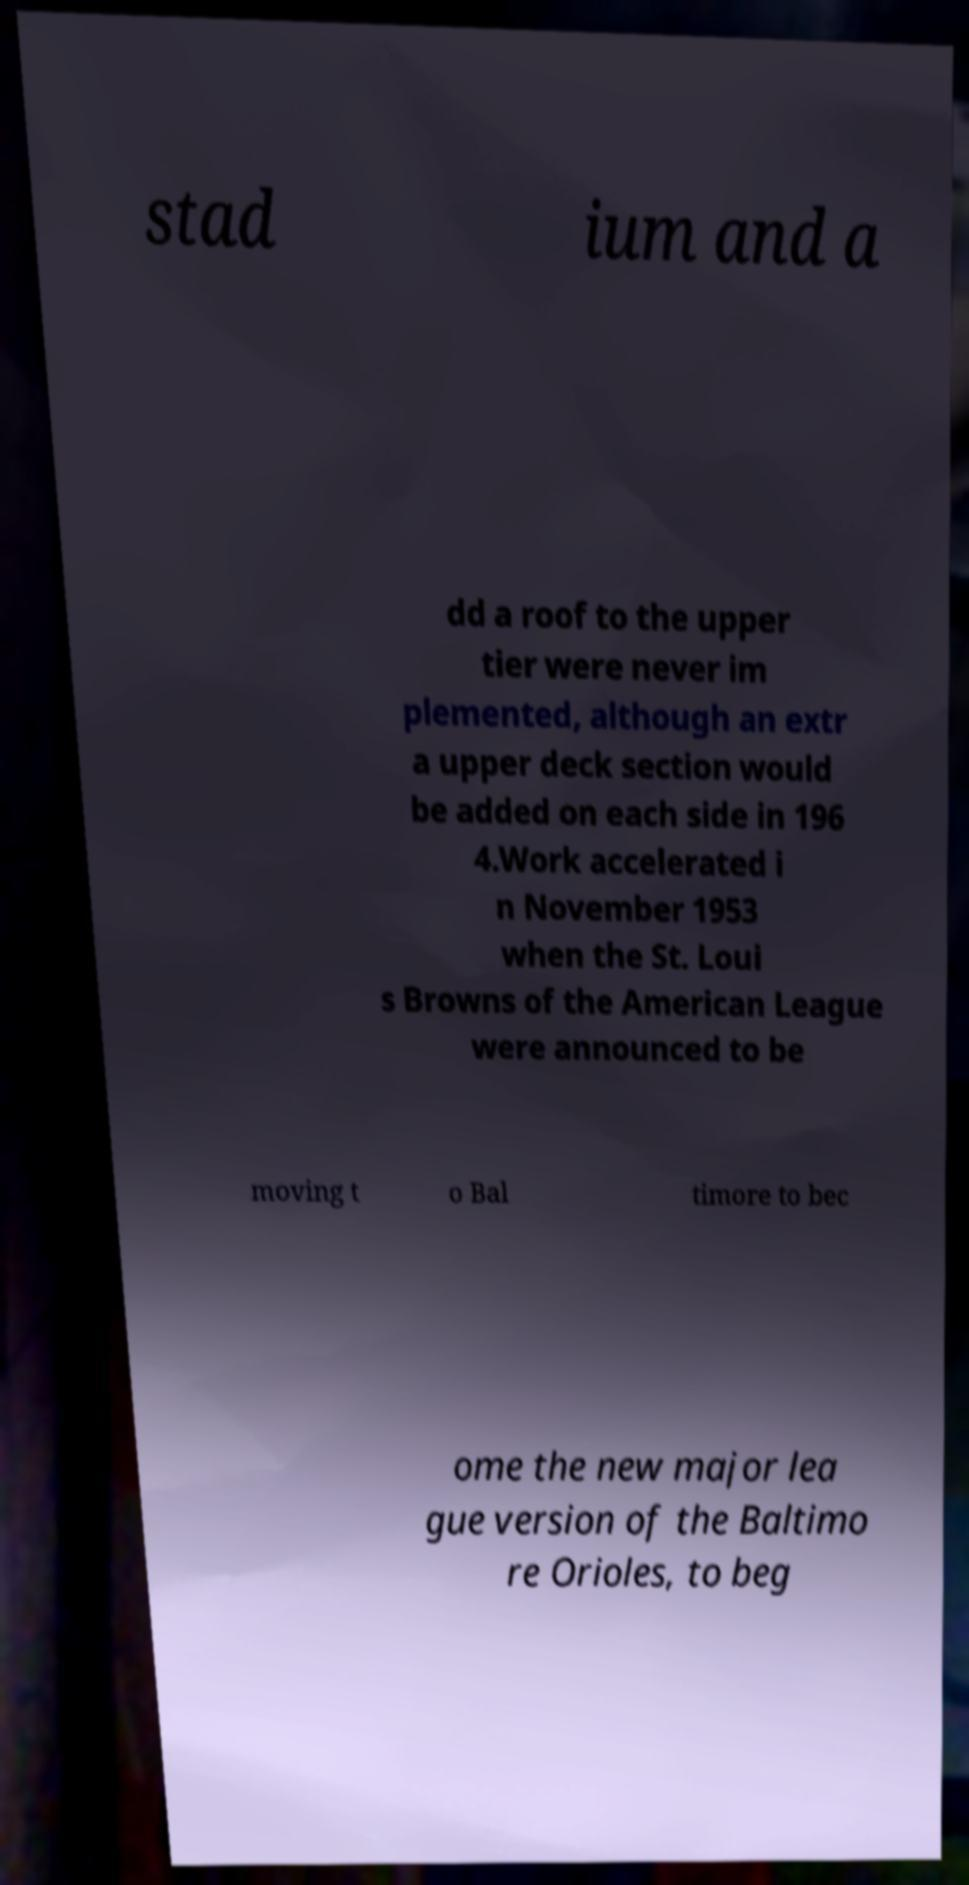Could you extract and type out the text from this image? stad ium and a dd a roof to the upper tier were never im plemented, although an extr a upper deck section would be added on each side in 196 4.Work accelerated i n November 1953 when the St. Loui s Browns of the American League were announced to be moving t o Bal timore to bec ome the new major lea gue version of the Baltimo re Orioles, to beg 